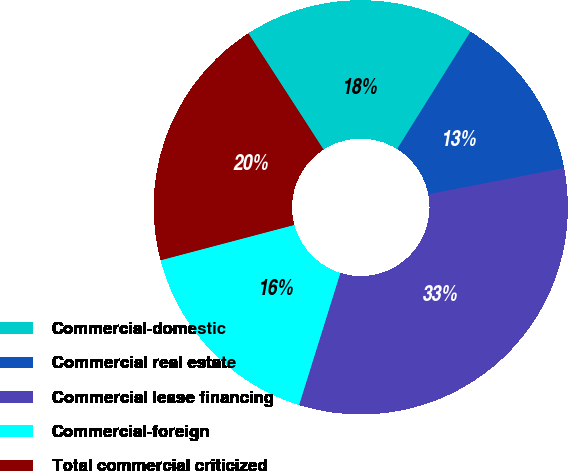Convert chart to OTSL. <chart><loc_0><loc_0><loc_500><loc_500><pie_chart><fcel>Commercial-domestic<fcel>Commercial real estate<fcel>Commercial lease financing<fcel>Commercial-foreign<fcel>Total commercial criticized<nl><fcel>18.02%<fcel>13.08%<fcel>32.85%<fcel>16.07%<fcel>19.98%<nl></chart> 